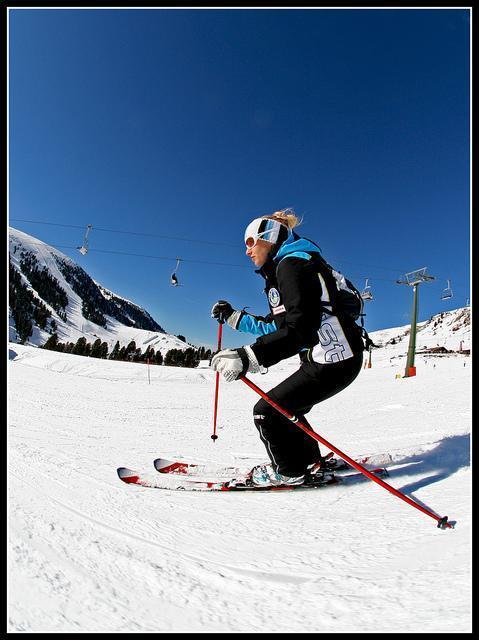How many blue bottles is this baby girl looking at?
Give a very brief answer. 0. 